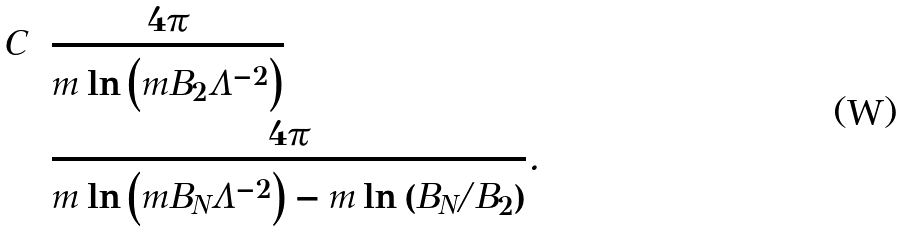Convert formula to latex. <formula><loc_0><loc_0><loc_500><loc_500>C & = \frac { 4 \pi } { m \ln \left ( m B _ { 2 } \Lambda ^ { - 2 } \right ) } \\ & = \frac { 4 \pi } { m \ln \left ( m B _ { N } \Lambda ^ { - 2 } \right ) - m \ln \left ( B _ { N } / B _ { 2 } \right ) } .</formula> 